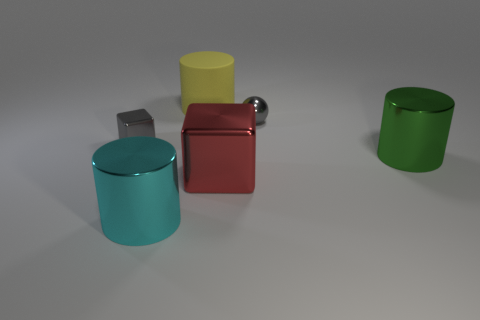What materials do the objects in the image appear to be made of? The objects in the image appear to have metallic surfaces with reflective properties, suggesting that they could be made of materials like polished aluminum or stainless steel, which are known for their lustrous finish. 